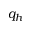Convert formula to latex. <formula><loc_0><loc_0><loc_500><loc_500>q _ { h }</formula> 